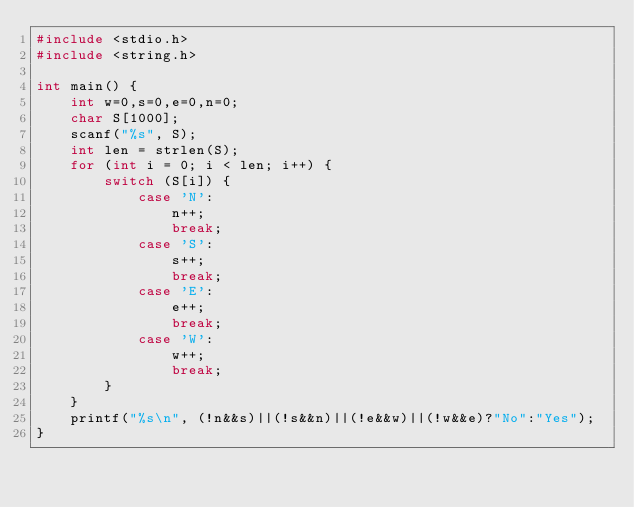<code> <loc_0><loc_0><loc_500><loc_500><_C_>#include <stdio.h>
#include <string.h>

int main() {
    int w=0,s=0,e=0,n=0;
    char S[1000];
    scanf("%s", S);
    int len = strlen(S);
    for (int i = 0; i < len; i++) {
        switch (S[i]) {
            case 'N':
                n++;
                break;
            case 'S':
                s++;
                break;
            case 'E':
                e++;
                break;
            case 'W':
                w++;
                break;
        }
    }
    printf("%s\n", (!n&&s)||(!s&&n)||(!e&&w)||(!w&&e)?"No":"Yes");
}
</code> 